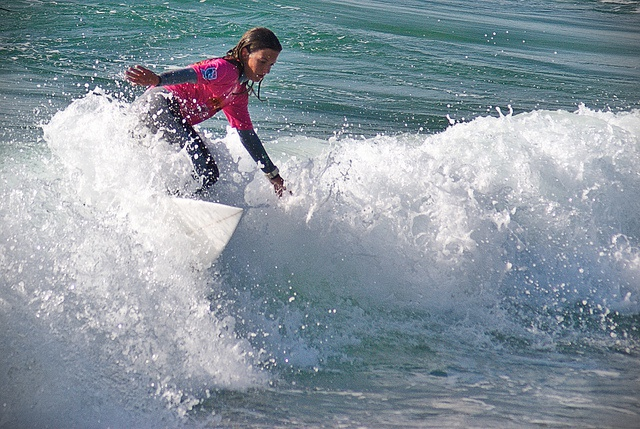Describe the objects in this image and their specific colors. I can see people in teal, black, lightgray, maroon, and darkgray tones and surfboard in teal, lightgray, darkgray, and gray tones in this image. 